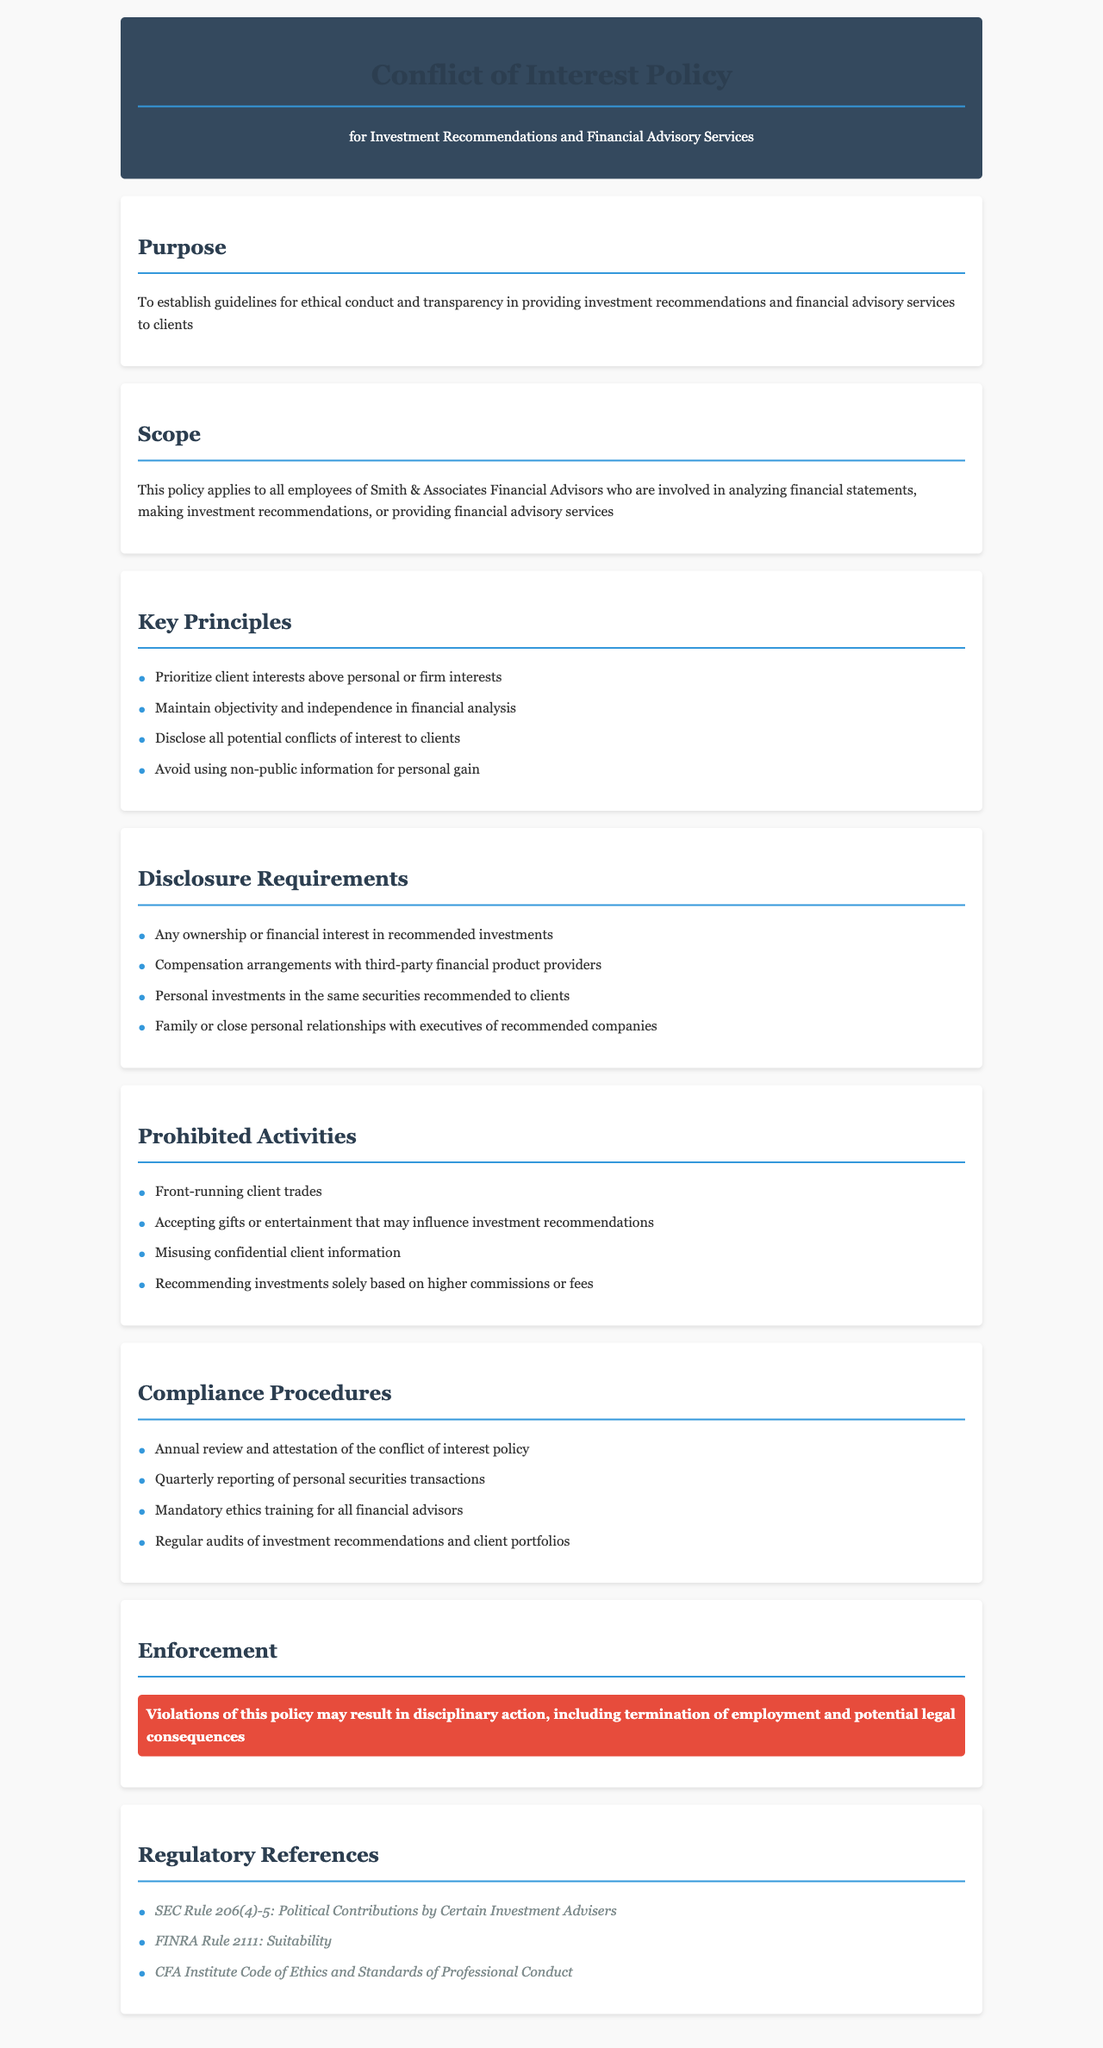What is the title of the policy document? The title of the policy document is stated at the top of the document, which establishes its main subject.
Answer: Conflict of Interest Policy Who does the policy apply to? The scope section indicates the specific group of individuals to whom the policy is relevant.
Answer: All employees of Smith & Associates Financial Advisors What is one key principle outlined in the document? The key principles are listed under the respective section, summarizing the ethical expectations.
Answer: Prioritize client interests above personal or firm interests What must be disclosed to clients? The document details specific information that must be shared with clients, located in the disclosure requirements section.
Answer: Any ownership or financial interest in recommended investments What acts are prohibited according to the policy? The prohibited activities section clearly outlines behaviors that are not allowed under the policy for ethical conduct.
Answer: Front-running client trades What kind of training is mandatory for financial advisors? The compliance procedures section specifies a particular type of training required for personnel involved in financial advising.
Answer: Mandatory ethics training What may happen if the policy is violated? The enforcement section describes the potential consequences of violating the policy, emphasizing accountability.
Answer: Disciplinary action How often must personal securities transactions be reported? The compliance section includes a specified frequency for reporting transactions, which is part of the internal controls established.
Answer: Quarterly Which regulatory reference addresses suitability? The regulatory references section includes various regulations and rules; one specifically pertains to the suitability of practices.
Answer: FINRA Rule 2111: Suitability 